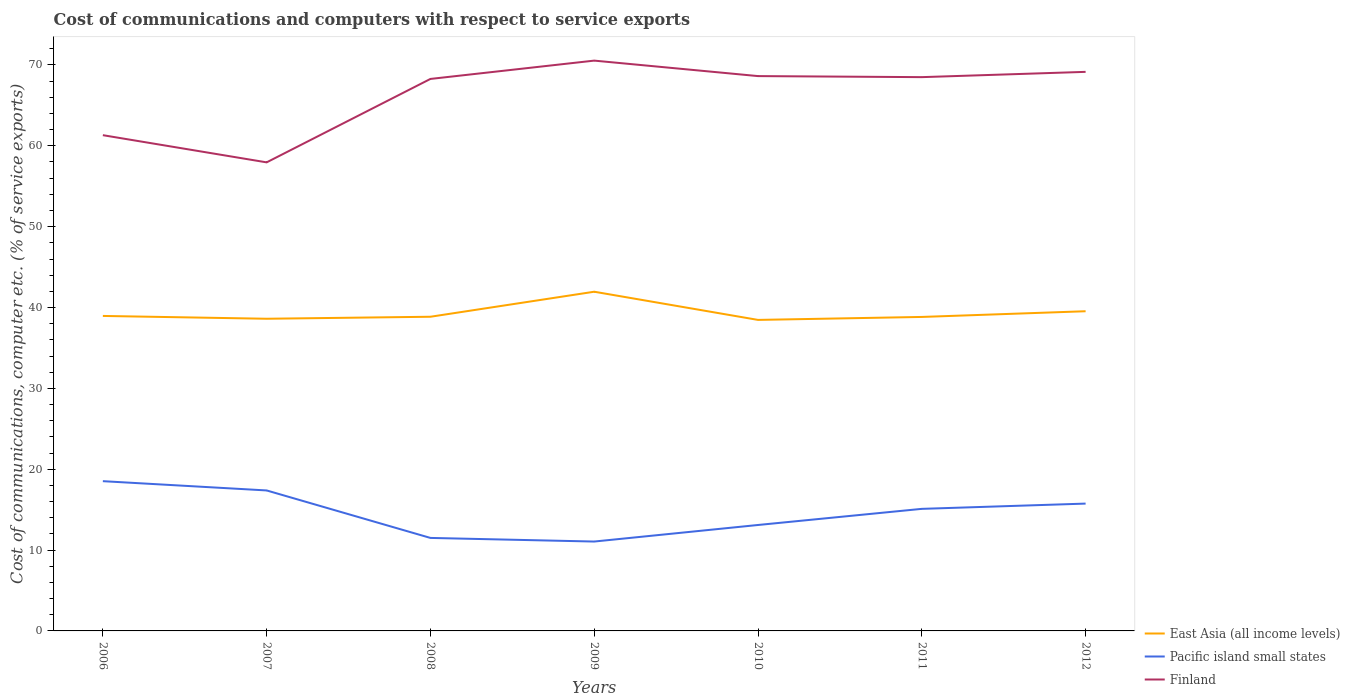Is the number of lines equal to the number of legend labels?
Your response must be concise. Yes. Across all years, what is the maximum cost of communications and computers in Finland?
Offer a very short reply. 57.95. What is the total cost of communications and computers in East Asia (all income levels) in the graph?
Provide a succinct answer. -0.25. What is the difference between the highest and the second highest cost of communications and computers in Finland?
Ensure brevity in your answer.  12.58. What is the difference between the highest and the lowest cost of communications and computers in East Asia (all income levels)?
Your answer should be compact. 2. Is the cost of communications and computers in Pacific island small states strictly greater than the cost of communications and computers in East Asia (all income levels) over the years?
Keep it short and to the point. Yes. Does the graph contain grids?
Offer a terse response. No. Where does the legend appear in the graph?
Offer a very short reply. Bottom right. What is the title of the graph?
Keep it short and to the point. Cost of communications and computers with respect to service exports. What is the label or title of the Y-axis?
Keep it short and to the point. Cost of communications, computer etc. (% of service exports). What is the Cost of communications, computer etc. (% of service exports) of East Asia (all income levels) in 2006?
Your answer should be very brief. 38.96. What is the Cost of communications, computer etc. (% of service exports) of Pacific island small states in 2006?
Keep it short and to the point. 18.52. What is the Cost of communications, computer etc. (% of service exports) in Finland in 2006?
Provide a succinct answer. 61.32. What is the Cost of communications, computer etc. (% of service exports) of East Asia (all income levels) in 2007?
Provide a short and direct response. 38.61. What is the Cost of communications, computer etc. (% of service exports) in Pacific island small states in 2007?
Provide a short and direct response. 17.37. What is the Cost of communications, computer etc. (% of service exports) of Finland in 2007?
Offer a very short reply. 57.95. What is the Cost of communications, computer etc. (% of service exports) of East Asia (all income levels) in 2008?
Your response must be concise. 38.86. What is the Cost of communications, computer etc. (% of service exports) in Pacific island small states in 2008?
Your response must be concise. 11.5. What is the Cost of communications, computer etc. (% of service exports) of Finland in 2008?
Keep it short and to the point. 68.27. What is the Cost of communications, computer etc. (% of service exports) in East Asia (all income levels) in 2009?
Ensure brevity in your answer.  41.95. What is the Cost of communications, computer etc. (% of service exports) in Pacific island small states in 2009?
Offer a very short reply. 11.06. What is the Cost of communications, computer etc. (% of service exports) in Finland in 2009?
Your answer should be compact. 70.54. What is the Cost of communications, computer etc. (% of service exports) of East Asia (all income levels) in 2010?
Your response must be concise. 38.47. What is the Cost of communications, computer etc. (% of service exports) in Pacific island small states in 2010?
Make the answer very short. 13.1. What is the Cost of communications, computer etc. (% of service exports) in Finland in 2010?
Ensure brevity in your answer.  68.62. What is the Cost of communications, computer etc. (% of service exports) in East Asia (all income levels) in 2011?
Make the answer very short. 38.84. What is the Cost of communications, computer etc. (% of service exports) in Pacific island small states in 2011?
Your answer should be very brief. 15.1. What is the Cost of communications, computer etc. (% of service exports) in Finland in 2011?
Your response must be concise. 68.5. What is the Cost of communications, computer etc. (% of service exports) in East Asia (all income levels) in 2012?
Ensure brevity in your answer.  39.54. What is the Cost of communications, computer etc. (% of service exports) in Pacific island small states in 2012?
Your response must be concise. 15.75. What is the Cost of communications, computer etc. (% of service exports) in Finland in 2012?
Give a very brief answer. 69.15. Across all years, what is the maximum Cost of communications, computer etc. (% of service exports) of East Asia (all income levels)?
Give a very brief answer. 41.95. Across all years, what is the maximum Cost of communications, computer etc. (% of service exports) in Pacific island small states?
Provide a short and direct response. 18.52. Across all years, what is the maximum Cost of communications, computer etc. (% of service exports) in Finland?
Provide a succinct answer. 70.54. Across all years, what is the minimum Cost of communications, computer etc. (% of service exports) of East Asia (all income levels)?
Offer a terse response. 38.47. Across all years, what is the minimum Cost of communications, computer etc. (% of service exports) in Pacific island small states?
Give a very brief answer. 11.06. Across all years, what is the minimum Cost of communications, computer etc. (% of service exports) of Finland?
Keep it short and to the point. 57.95. What is the total Cost of communications, computer etc. (% of service exports) of East Asia (all income levels) in the graph?
Keep it short and to the point. 275.23. What is the total Cost of communications, computer etc. (% of service exports) of Pacific island small states in the graph?
Your answer should be very brief. 102.4. What is the total Cost of communications, computer etc. (% of service exports) in Finland in the graph?
Your answer should be compact. 464.35. What is the difference between the Cost of communications, computer etc. (% of service exports) of East Asia (all income levels) in 2006 and that in 2007?
Offer a very short reply. 0.35. What is the difference between the Cost of communications, computer etc. (% of service exports) of Pacific island small states in 2006 and that in 2007?
Your response must be concise. 1.15. What is the difference between the Cost of communications, computer etc. (% of service exports) in Finland in 2006 and that in 2007?
Your answer should be compact. 3.36. What is the difference between the Cost of communications, computer etc. (% of service exports) of East Asia (all income levels) in 2006 and that in 2008?
Your response must be concise. 0.1. What is the difference between the Cost of communications, computer etc. (% of service exports) in Pacific island small states in 2006 and that in 2008?
Your answer should be very brief. 7.02. What is the difference between the Cost of communications, computer etc. (% of service exports) of Finland in 2006 and that in 2008?
Your answer should be compact. -6.96. What is the difference between the Cost of communications, computer etc. (% of service exports) of East Asia (all income levels) in 2006 and that in 2009?
Your response must be concise. -2.99. What is the difference between the Cost of communications, computer etc. (% of service exports) in Pacific island small states in 2006 and that in 2009?
Provide a short and direct response. 7.47. What is the difference between the Cost of communications, computer etc. (% of service exports) of Finland in 2006 and that in 2009?
Ensure brevity in your answer.  -9.22. What is the difference between the Cost of communications, computer etc. (% of service exports) in East Asia (all income levels) in 2006 and that in 2010?
Your answer should be compact. 0.49. What is the difference between the Cost of communications, computer etc. (% of service exports) of Pacific island small states in 2006 and that in 2010?
Your response must be concise. 5.42. What is the difference between the Cost of communications, computer etc. (% of service exports) of Finland in 2006 and that in 2010?
Give a very brief answer. -7.31. What is the difference between the Cost of communications, computer etc. (% of service exports) of East Asia (all income levels) in 2006 and that in 2011?
Provide a succinct answer. 0.12. What is the difference between the Cost of communications, computer etc. (% of service exports) of Pacific island small states in 2006 and that in 2011?
Provide a short and direct response. 3.42. What is the difference between the Cost of communications, computer etc. (% of service exports) in Finland in 2006 and that in 2011?
Your answer should be very brief. -7.18. What is the difference between the Cost of communications, computer etc. (% of service exports) of East Asia (all income levels) in 2006 and that in 2012?
Your answer should be compact. -0.58. What is the difference between the Cost of communications, computer etc. (% of service exports) in Pacific island small states in 2006 and that in 2012?
Offer a terse response. 2.77. What is the difference between the Cost of communications, computer etc. (% of service exports) in Finland in 2006 and that in 2012?
Make the answer very short. -7.83. What is the difference between the Cost of communications, computer etc. (% of service exports) of East Asia (all income levels) in 2007 and that in 2008?
Ensure brevity in your answer.  -0.25. What is the difference between the Cost of communications, computer etc. (% of service exports) of Pacific island small states in 2007 and that in 2008?
Provide a succinct answer. 5.87. What is the difference between the Cost of communications, computer etc. (% of service exports) of Finland in 2007 and that in 2008?
Ensure brevity in your answer.  -10.32. What is the difference between the Cost of communications, computer etc. (% of service exports) in East Asia (all income levels) in 2007 and that in 2009?
Your answer should be compact. -3.34. What is the difference between the Cost of communications, computer etc. (% of service exports) in Pacific island small states in 2007 and that in 2009?
Give a very brief answer. 6.32. What is the difference between the Cost of communications, computer etc. (% of service exports) in Finland in 2007 and that in 2009?
Provide a short and direct response. -12.58. What is the difference between the Cost of communications, computer etc. (% of service exports) of East Asia (all income levels) in 2007 and that in 2010?
Make the answer very short. 0.14. What is the difference between the Cost of communications, computer etc. (% of service exports) of Pacific island small states in 2007 and that in 2010?
Your answer should be compact. 4.27. What is the difference between the Cost of communications, computer etc. (% of service exports) of Finland in 2007 and that in 2010?
Your answer should be very brief. -10.67. What is the difference between the Cost of communications, computer etc. (% of service exports) of East Asia (all income levels) in 2007 and that in 2011?
Ensure brevity in your answer.  -0.22. What is the difference between the Cost of communications, computer etc. (% of service exports) of Pacific island small states in 2007 and that in 2011?
Give a very brief answer. 2.28. What is the difference between the Cost of communications, computer etc. (% of service exports) of Finland in 2007 and that in 2011?
Make the answer very short. -10.54. What is the difference between the Cost of communications, computer etc. (% of service exports) in East Asia (all income levels) in 2007 and that in 2012?
Make the answer very short. -0.93. What is the difference between the Cost of communications, computer etc. (% of service exports) of Pacific island small states in 2007 and that in 2012?
Offer a terse response. 1.63. What is the difference between the Cost of communications, computer etc. (% of service exports) of Finland in 2007 and that in 2012?
Make the answer very short. -11.19. What is the difference between the Cost of communications, computer etc. (% of service exports) of East Asia (all income levels) in 2008 and that in 2009?
Your response must be concise. -3.1. What is the difference between the Cost of communications, computer etc. (% of service exports) of Pacific island small states in 2008 and that in 2009?
Your answer should be very brief. 0.45. What is the difference between the Cost of communications, computer etc. (% of service exports) in Finland in 2008 and that in 2009?
Offer a terse response. -2.26. What is the difference between the Cost of communications, computer etc. (% of service exports) of East Asia (all income levels) in 2008 and that in 2010?
Provide a short and direct response. 0.39. What is the difference between the Cost of communications, computer etc. (% of service exports) of Pacific island small states in 2008 and that in 2010?
Keep it short and to the point. -1.6. What is the difference between the Cost of communications, computer etc. (% of service exports) in Finland in 2008 and that in 2010?
Make the answer very short. -0.35. What is the difference between the Cost of communications, computer etc. (% of service exports) in East Asia (all income levels) in 2008 and that in 2011?
Make the answer very short. 0.02. What is the difference between the Cost of communications, computer etc. (% of service exports) of Pacific island small states in 2008 and that in 2011?
Give a very brief answer. -3.6. What is the difference between the Cost of communications, computer etc. (% of service exports) in Finland in 2008 and that in 2011?
Your answer should be very brief. -0.22. What is the difference between the Cost of communications, computer etc. (% of service exports) in East Asia (all income levels) in 2008 and that in 2012?
Keep it short and to the point. -0.68. What is the difference between the Cost of communications, computer etc. (% of service exports) of Pacific island small states in 2008 and that in 2012?
Provide a succinct answer. -4.25. What is the difference between the Cost of communications, computer etc. (% of service exports) of Finland in 2008 and that in 2012?
Your response must be concise. -0.87. What is the difference between the Cost of communications, computer etc. (% of service exports) in East Asia (all income levels) in 2009 and that in 2010?
Your answer should be very brief. 3.49. What is the difference between the Cost of communications, computer etc. (% of service exports) in Pacific island small states in 2009 and that in 2010?
Your answer should be compact. -2.05. What is the difference between the Cost of communications, computer etc. (% of service exports) in Finland in 2009 and that in 2010?
Make the answer very short. 1.91. What is the difference between the Cost of communications, computer etc. (% of service exports) in East Asia (all income levels) in 2009 and that in 2011?
Your response must be concise. 3.12. What is the difference between the Cost of communications, computer etc. (% of service exports) in Pacific island small states in 2009 and that in 2011?
Your answer should be very brief. -4.04. What is the difference between the Cost of communications, computer etc. (% of service exports) of Finland in 2009 and that in 2011?
Give a very brief answer. 2.04. What is the difference between the Cost of communications, computer etc. (% of service exports) in East Asia (all income levels) in 2009 and that in 2012?
Give a very brief answer. 2.41. What is the difference between the Cost of communications, computer etc. (% of service exports) in Pacific island small states in 2009 and that in 2012?
Make the answer very short. -4.69. What is the difference between the Cost of communications, computer etc. (% of service exports) in Finland in 2009 and that in 2012?
Your response must be concise. 1.39. What is the difference between the Cost of communications, computer etc. (% of service exports) of East Asia (all income levels) in 2010 and that in 2011?
Offer a terse response. -0.37. What is the difference between the Cost of communications, computer etc. (% of service exports) in Pacific island small states in 2010 and that in 2011?
Make the answer very short. -2. What is the difference between the Cost of communications, computer etc. (% of service exports) of Finland in 2010 and that in 2011?
Ensure brevity in your answer.  0.13. What is the difference between the Cost of communications, computer etc. (% of service exports) of East Asia (all income levels) in 2010 and that in 2012?
Make the answer very short. -1.07. What is the difference between the Cost of communications, computer etc. (% of service exports) in Pacific island small states in 2010 and that in 2012?
Offer a terse response. -2.65. What is the difference between the Cost of communications, computer etc. (% of service exports) of Finland in 2010 and that in 2012?
Offer a terse response. -0.52. What is the difference between the Cost of communications, computer etc. (% of service exports) in East Asia (all income levels) in 2011 and that in 2012?
Your answer should be very brief. -0.71. What is the difference between the Cost of communications, computer etc. (% of service exports) of Pacific island small states in 2011 and that in 2012?
Give a very brief answer. -0.65. What is the difference between the Cost of communications, computer etc. (% of service exports) of Finland in 2011 and that in 2012?
Your answer should be compact. -0.65. What is the difference between the Cost of communications, computer etc. (% of service exports) in East Asia (all income levels) in 2006 and the Cost of communications, computer etc. (% of service exports) in Pacific island small states in 2007?
Give a very brief answer. 21.58. What is the difference between the Cost of communications, computer etc. (% of service exports) of East Asia (all income levels) in 2006 and the Cost of communications, computer etc. (% of service exports) of Finland in 2007?
Keep it short and to the point. -19. What is the difference between the Cost of communications, computer etc. (% of service exports) of Pacific island small states in 2006 and the Cost of communications, computer etc. (% of service exports) of Finland in 2007?
Your answer should be very brief. -39.43. What is the difference between the Cost of communications, computer etc. (% of service exports) of East Asia (all income levels) in 2006 and the Cost of communications, computer etc. (% of service exports) of Pacific island small states in 2008?
Provide a succinct answer. 27.46. What is the difference between the Cost of communications, computer etc. (% of service exports) in East Asia (all income levels) in 2006 and the Cost of communications, computer etc. (% of service exports) in Finland in 2008?
Provide a succinct answer. -29.31. What is the difference between the Cost of communications, computer etc. (% of service exports) of Pacific island small states in 2006 and the Cost of communications, computer etc. (% of service exports) of Finland in 2008?
Make the answer very short. -49.75. What is the difference between the Cost of communications, computer etc. (% of service exports) in East Asia (all income levels) in 2006 and the Cost of communications, computer etc. (% of service exports) in Pacific island small states in 2009?
Give a very brief answer. 27.9. What is the difference between the Cost of communications, computer etc. (% of service exports) in East Asia (all income levels) in 2006 and the Cost of communications, computer etc. (% of service exports) in Finland in 2009?
Your answer should be compact. -31.58. What is the difference between the Cost of communications, computer etc. (% of service exports) of Pacific island small states in 2006 and the Cost of communications, computer etc. (% of service exports) of Finland in 2009?
Provide a short and direct response. -52.02. What is the difference between the Cost of communications, computer etc. (% of service exports) of East Asia (all income levels) in 2006 and the Cost of communications, computer etc. (% of service exports) of Pacific island small states in 2010?
Your answer should be very brief. 25.86. What is the difference between the Cost of communications, computer etc. (% of service exports) of East Asia (all income levels) in 2006 and the Cost of communications, computer etc. (% of service exports) of Finland in 2010?
Make the answer very short. -29.67. What is the difference between the Cost of communications, computer etc. (% of service exports) in Pacific island small states in 2006 and the Cost of communications, computer etc. (% of service exports) in Finland in 2010?
Provide a succinct answer. -50.1. What is the difference between the Cost of communications, computer etc. (% of service exports) in East Asia (all income levels) in 2006 and the Cost of communications, computer etc. (% of service exports) in Pacific island small states in 2011?
Your response must be concise. 23.86. What is the difference between the Cost of communications, computer etc. (% of service exports) in East Asia (all income levels) in 2006 and the Cost of communications, computer etc. (% of service exports) in Finland in 2011?
Ensure brevity in your answer.  -29.54. What is the difference between the Cost of communications, computer etc. (% of service exports) of Pacific island small states in 2006 and the Cost of communications, computer etc. (% of service exports) of Finland in 2011?
Make the answer very short. -49.97. What is the difference between the Cost of communications, computer etc. (% of service exports) in East Asia (all income levels) in 2006 and the Cost of communications, computer etc. (% of service exports) in Pacific island small states in 2012?
Give a very brief answer. 23.21. What is the difference between the Cost of communications, computer etc. (% of service exports) of East Asia (all income levels) in 2006 and the Cost of communications, computer etc. (% of service exports) of Finland in 2012?
Offer a very short reply. -30.19. What is the difference between the Cost of communications, computer etc. (% of service exports) in Pacific island small states in 2006 and the Cost of communications, computer etc. (% of service exports) in Finland in 2012?
Your response must be concise. -50.63. What is the difference between the Cost of communications, computer etc. (% of service exports) of East Asia (all income levels) in 2007 and the Cost of communications, computer etc. (% of service exports) of Pacific island small states in 2008?
Offer a terse response. 27.11. What is the difference between the Cost of communications, computer etc. (% of service exports) in East Asia (all income levels) in 2007 and the Cost of communications, computer etc. (% of service exports) in Finland in 2008?
Your answer should be very brief. -29.66. What is the difference between the Cost of communications, computer etc. (% of service exports) in Pacific island small states in 2007 and the Cost of communications, computer etc. (% of service exports) in Finland in 2008?
Make the answer very short. -50.9. What is the difference between the Cost of communications, computer etc. (% of service exports) of East Asia (all income levels) in 2007 and the Cost of communications, computer etc. (% of service exports) of Pacific island small states in 2009?
Provide a succinct answer. 27.56. What is the difference between the Cost of communications, computer etc. (% of service exports) in East Asia (all income levels) in 2007 and the Cost of communications, computer etc. (% of service exports) in Finland in 2009?
Provide a short and direct response. -31.93. What is the difference between the Cost of communications, computer etc. (% of service exports) of Pacific island small states in 2007 and the Cost of communications, computer etc. (% of service exports) of Finland in 2009?
Give a very brief answer. -53.16. What is the difference between the Cost of communications, computer etc. (% of service exports) of East Asia (all income levels) in 2007 and the Cost of communications, computer etc. (% of service exports) of Pacific island small states in 2010?
Your response must be concise. 25.51. What is the difference between the Cost of communications, computer etc. (% of service exports) of East Asia (all income levels) in 2007 and the Cost of communications, computer etc. (% of service exports) of Finland in 2010?
Offer a very short reply. -30.01. What is the difference between the Cost of communications, computer etc. (% of service exports) in Pacific island small states in 2007 and the Cost of communications, computer etc. (% of service exports) in Finland in 2010?
Give a very brief answer. -51.25. What is the difference between the Cost of communications, computer etc. (% of service exports) in East Asia (all income levels) in 2007 and the Cost of communications, computer etc. (% of service exports) in Pacific island small states in 2011?
Your response must be concise. 23.51. What is the difference between the Cost of communications, computer etc. (% of service exports) in East Asia (all income levels) in 2007 and the Cost of communications, computer etc. (% of service exports) in Finland in 2011?
Give a very brief answer. -29.88. What is the difference between the Cost of communications, computer etc. (% of service exports) in Pacific island small states in 2007 and the Cost of communications, computer etc. (% of service exports) in Finland in 2011?
Offer a terse response. -51.12. What is the difference between the Cost of communications, computer etc. (% of service exports) of East Asia (all income levels) in 2007 and the Cost of communications, computer etc. (% of service exports) of Pacific island small states in 2012?
Keep it short and to the point. 22.86. What is the difference between the Cost of communications, computer etc. (% of service exports) in East Asia (all income levels) in 2007 and the Cost of communications, computer etc. (% of service exports) in Finland in 2012?
Offer a terse response. -30.54. What is the difference between the Cost of communications, computer etc. (% of service exports) in Pacific island small states in 2007 and the Cost of communications, computer etc. (% of service exports) in Finland in 2012?
Provide a succinct answer. -51.77. What is the difference between the Cost of communications, computer etc. (% of service exports) in East Asia (all income levels) in 2008 and the Cost of communications, computer etc. (% of service exports) in Pacific island small states in 2009?
Your answer should be compact. 27.8. What is the difference between the Cost of communications, computer etc. (% of service exports) in East Asia (all income levels) in 2008 and the Cost of communications, computer etc. (% of service exports) in Finland in 2009?
Make the answer very short. -31.68. What is the difference between the Cost of communications, computer etc. (% of service exports) in Pacific island small states in 2008 and the Cost of communications, computer etc. (% of service exports) in Finland in 2009?
Provide a succinct answer. -59.04. What is the difference between the Cost of communications, computer etc. (% of service exports) of East Asia (all income levels) in 2008 and the Cost of communications, computer etc. (% of service exports) of Pacific island small states in 2010?
Provide a succinct answer. 25.76. What is the difference between the Cost of communications, computer etc. (% of service exports) of East Asia (all income levels) in 2008 and the Cost of communications, computer etc. (% of service exports) of Finland in 2010?
Your response must be concise. -29.77. What is the difference between the Cost of communications, computer etc. (% of service exports) in Pacific island small states in 2008 and the Cost of communications, computer etc. (% of service exports) in Finland in 2010?
Your answer should be very brief. -57.12. What is the difference between the Cost of communications, computer etc. (% of service exports) of East Asia (all income levels) in 2008 and the Cost of communications, computer etc. (% of service exports) of Pacific island small states in 2011?
Offer a terse response. 23.76. What is the difference between the Cost of communications, computer etc. (% of service exports) of East Asia (all income levels) in 2008 and the Cost of communications, computer etc. (% of service exports) of Finland in 2011?
Provide a short and direct response. -29.64. What is the difference between the Cost of communications, computer etc. (% of service exports) in Pacific island small states in 2008 and the Cost of communications, computer etc. (% of service exports) in Finland in 2011?
Provide a succinct answer. -56.99. What is the difference between the Cost of communications, computer etc. (% of service exports) in East Asia (all income levels) in 2008 and the Cost of communications, computer etc. (% of service exports) in Pacific island small states in 2012?
Keep it short and to the point. 23.11. What is the difference between the Cost of communications, computer etc. (% of service exports) in East Asia (all income levels) in 2008 and the Cost of communications, computer etc. (% of service exports) in Finland in 2012?
Offer a very short reply. -30.29. What is the difference between the Cost of communications, computer etc. (% of service exports) in Pacific island small states in 2008 and the Cost of communications, computer etc. (% of service exports) in Finland in 2012?
Make the answer very short. -57.65. What is the difference between the Cost of communications, computer etc. (% of service exports) of East Asia (all income levels) in 2009 and the Cost of communications, computer etc. (% of service exports) of Pacific island small states in 2010?
Ensure brevity in your answer.  28.85. What is the difference between the Cost of communications, computer etc. (% of service exports) of East Asia (all income levels) in 2009 and the Cost of communications, computer etc. (% of service exports) of Finland in 2010?
Provide a succinct answer. -26.67. What is the difference between the Cost of communications, computer etc. (% of service exports) of Pacific island small states in 2009 and the Cost of communications, computer etc. (% of service exports) of Finland in 2010?
Give a very brief answer. -57.57. What is the difference between the Cost of communications, computer etc. (% of service exports) of East Asia (all income levels) in 2009 and the Cost of communications, computer etc. (% of service exports) of Pacific island small states in 2011?
Keep it short and to the point. 26.86. What is the difference between the Cost of communications, computer etc. (% of service exports) of East Asia (all income levels) in 2009 and the Cost of communications, computer etc. (% of service exports) of Finland in 2011?
Your response must be concise. -26.54. What is the difference between the Cost of communications, computer etc. (% of service exports) in Pacific island small states in 2009 and the Cost of communications, computer etc. (% of service exports) in Finland in 2011?
Your response must be concise. -57.44. What is the difference between the Cost of communications, computer etc. (% of service exports) in East Asia (all income levels) in 2009 and the Cost of communications, computer etc. (% of service exports) in Pacific island small states in 2012?
Your answer should be compact. 26.2. What is the difference between the Cost of communications, computer etc. (% of service exports) in East Asia (all income levels) in 2009 and the Cost of communications, computer etc. (% of service exports) in Finland in 2012?
Make the answer very short. -27.19. What is the difference between the Cost of communications, computer etc. (% of service exports) of Pacific island small states in 2009 and the Cost of communications, computer etc. (% of service exports) of Finland in 2012?
Your answer should be compact. -58.09. What is the difference between the Cost of communications, computer etc. (% of service exports) of East Asia (all income levels) in 2010 and the Cost of communications, computer etc. (% of service exports) of Pacific island small states in 2011?
Offer a very short reply. 23.37. What is the difference between the Cost of communications, computer etc. (% of service exports) of East Asia (all income levels) in 2010 and the Cost of communications, computer etc. (% of service exports) of Finland in 2011?
Ensure brevity in your answer.  -30.03. What is the difference between the Cost of communications, computer etc. (% of service exports) of Pacific island small states in 2010 and the Cost of communications, computer etc. (% of service exports) of Finland in 2011?
Ensure brevity in your answer.  -55.39. What is the difference between the Cost of communications, computer etc. (% of service exports) in East Asia (all income levels) in 2010 and the Cost of communications, computer etc. (% of service exports) in Pacific island small states in 2012?
Provide a succinct answer. 22.72. What is the difference between the Cost of communications, computer etc. (% of service exports) of East Asia (all income levels) in 2010 and the Cost of communications, computer etc. (% of service exports) of Finland in 2012?
Your answer should be very brief. -30.68. What is the difference between the Cost of communications, computer etc. (% of service exports) of Pacific island small states in 2010 and the Cost of communications, computer etc. (% of service exports) of Finland in 2012?
Give a very brief answer. -56.04. What is the difference between the Cost of communications, computer etc. (% of service exports) of East Asia (all income levels) in 2011 and the Cost of communications, computer etc. (% of service exports) of Pacific island small states in 2012?
Your response must be concise. 23.09. What is the difference between the Cost of communications, computer etc. (% of service exports) of East Asia (all income levels) in 2011 and the Cost of communications, computer etc. (% of service exports) of Finland in 2012?
Your answer should be compact. -30.31. What is the difference between the Cost of communications, computer etc. (% of service exports) in Pacific island small states in 2011 and the Cost of communications, computer etc. (% of service exports) in Finland in 2012?
Ensure brevity in your answer.  -54.05. What is the average Cost of communications, computer etc. (% of service exports) of East Asia (all income levels) per year?
Your answer should be very brief. 39.32. What is the average Cost of communications, computer etc. (% of service exports) in Pacific island small states per year?
Your answer should be compact. 14.63. What is the average Cost of communications, computer etc. (% of service exports) in Finland per year?
Give a very brief answer. 66.34. In the year 2006, what is the difference between the Cost of communications, computer etc. (% of service exports) in East Asia (all income levels) and Cost of communications, computer etc. (% of service exports) in Pacific island small states?
Offer a terse response. 20.44. In the year 2006, what is the difference between the Cost of communications, computer etc. (% of service exports) in East Asia (all income levels) and Cost of communications, computer etc. (% of service exports) in Finland?
Offer a very short reply. -22.36. In the year 2006, what is the difference between the Cost of communications, computer etc. (% of service exports) of Pacific island small states and Cost of communications, computer etc. (% of service exports) of Finland?
Offer a terse response. -42.8. In the year 2007, what is the difference between the Cost of communications, computer etc. (% of service exports) of East Asia (all income levels) and Cost of communications, computer etc. (% of service exports) of Pacific island small states?
Provide a short and direct response. 21.24. In the year 2007, what is the difference between the Cost of communications, computer etc. (% of service exports) in East Asia (all income levels) and Cost of communications, computer etc. (% of service exports) in Finland?
Offer a very short reply. -19.34. In the year 2007, what is the difference between the Cost of communications, computer etc. (% of service exports) in Pacific island small states and Cost of communications, computer etc. (% of service exports) in Finland?
Provide a succinct answer. -40.58. In the year 2008, what is the difference between the Cost of communications, computer etc. (% of service exports) in East Asia (all income levels) and Cost of communications, computer etc. (% of service exports) in Pacific island small states?
Offer a terse response. 27.36. In the year 2008, what is the difference between the Cost of communications, computer etc. (% of service exports) of East Asia (all income levels) and Cost of communications, computer etc. (% of service exports) of Finland?
Your answer should be compact. -29.42. In the year 2008, what is the difference between the Cost of communications, computer etc. (% of service exports) of Pacific island small states and Cost of communications, computer etc. (% of service exports) of Finland?
Make the answer very short. -56.77. In the year 2009, what is the difference between the Cost of communications, computer etc. (% of service exports) in East Asia (all income levels) and Cost of communications, computer etc. (% of service exports) in Pacific island small states?
Ensure brevity in your answer.  30.9. In the year 2009, what is the difference between the Cost of communications, computer etc. (% of service exports) in East Asia (all income levels) and Cost of communications, computer etc. (% of service exports) in Finland?
Your answer should be compact. -28.58. In the year 2009, what is the difference between the Cost of communications, computer etc. (% of service exports) in Pacific island small states and Cost of communications, computer etc. (% of service exports) in Finland?
Provide a succinct answer. -59.48. In the year 2010, what is the difference between the Cost of communications, computer etc. (% of service exports) of East Asia (all income levels) and Cost of communications, computer etc. (% of service exports) of Pacific island small states?
Your response must be concise. 25.36. In the year 2010, what is the difference between the Cost of communications, computer etc. (% of service exports) of East Asia (all income levels) and Cost of communications, computer etc. (% of service exports) of Finland?
Offer a terse response. -30.16. In the year 2010, what is the difference between the Cost of communications, computer etc. (% of service exports) in Pacific island small states and Cost of communications, computer etc. (% of service exports) in Finland?
Ensure brevity in your answer.  -55.52. In the year 2011, what is the difference between the Cost of communications, computer etc. (% of service exports) of East Asia (all income levels) and Cost of communications, computer etc. (% of service exports) of Pacific island small states?
Offer a terse response. 23.74. In the year 2011, what is the difference between the Cost of communications, computer etc. (% of service exports) in East Asia (all income levels) and Cost of communications, computer etc. (% of service exports) in Finland?
Ensure brevity in your answer.  -29.66. In the year 2011, what is the difference between the Cost of communications, computer etc. (% of service exports) of Pacific island small states and Cost of communications, computer etc. (% of service exports) of Finland?
Keep it short and to the point. -53.4. In the year 2012, what is the difference between the Cost of communications, computer etc. (% of service exports) of East Asia (all income levels) and Cost of communications, computer etc. (% of service exports) of Pacific island small states?
Your response must be concise. 23.79. In the year 2012, what is the difference between the Cost of communications, computer etc. (% of service exports) of East Asia (all income levels) and Cost of communications, computer etc. (% of service exports) of Finland?
Your response must be concise. -29.61. In the year 2012, what is the difference between the Cost of communications, computer etc. (% of service exports) in Pacific island small states and Cost of communications, computer etc. (% of service exports) in Finland?
Offer a terse response. -53.4. What is the ratio of the Cost of communications, computer etc. (% of service exports) in Pacific island small states in 2006 to that in 2007?
Make the answer very short. 1.07. What is the ratio of the Cost of communications, computer etc. (% of service exports) in Finland in 2006 to that in 2007?
Provide a short and direct response. 1.06. What is the ratio of the Cost of communications, computer etc. (% of service exports) of Pacific island small states in 2006 to that in 2008?
Your answer should be very brief. 1.61. What is the ratio of the Cost of communications, computer etc. (% of service exports) in Finland in 2006 to that in 2008?
Make the answer very short. 0.9. What is the ratio of the Cost of communications, computer etc. (% of service exports) of East Asia (all income levels) in 2006 to that in 2009?
Provide a short and direct response. 0.93. What is the ratio of the Cost of communications, computer etc. (% of service exports) of Pacific island small states in 2006 to that in 2009?
Your response must be concise. 1.68. What is the ratio of the Cost of communications, computer etc. (% of service exports) in Finland in 2006 to that in 2009?
Provide a succinct answer. 0.87. What is the ratio of the Cost of communications, computer etc. (% of service exports) of East Asia (all income levels) in 2006 to that in 2010?
Provide a short and direct response. 1.01. What is the ratio of the Cost of communications, computer etc. (% of service exports) in Pacific island small states in 2006 to that in 2010?
Ensure brevity in your answer.  1.41. What is the ratio of the Cost of communications, computer etc. (% of service exports) of Finland in 2006 to that in 2010?
Keep it short and to the point. 0.89. What is the ratio of the Cost of communications, computer etc. (% of service exports) of Pacific island small states in 2006 to that in 2011?
Offer a terse response. 1.23. What is the ratio of the Cost of communications, computer etc. (% of service exports) in Finland in 2006 to that in 2011?
Give a very brief answer. 0.9. What is the ratio of the Cost of communications, computer etc. (% of service exports) of Pacific island small states in 2006 to that in 2012?
Make the answer very short. 1.18. What is the ratio of the Cost of communications, computer etc. (% of service exports) of Finland in 2006 to that in 2012?
Offer a very short reply. 0.89. What is the ratio of the Cost of communications, computer etc. (% of service exports) in East Asia (all income levels) in 2007 to that in 2008?
Provide a short and direct response. 0.99. What is the ratio of the Cost of communications, computer etc. (% of service exports) in Pacific island small states in 2007 to that in 2008?
Your answer should be very brief. 1.51. What is the ratio of the Cost of communications, computer etc. (% of service exports) in Finland in 2007 to that in 2008?
Provide a short and direct response. 0.85. What is the ratio of the Cost of communications, computer etc. (% of service exports) in East Asia (all income levels) in 2007 to that in 2009?
Your response must be concise. 0.92. What is the ratio of the Cost of communications, computer etc. (% of service exports) in Pacific island small states in 2007 to that in 2009?
Provide a short and direct response. 1.57. What is the ratio of the Cost of communications, computer etc. (% of service exports) in Finland in 2007 to that in 2009?
Make the answer very short. 0.82. What is the ratio of the Cost of communications, computer etc. (% of service exports) of Pacific island small states in 2007 to that in 2010?
Give a very brief answer. 1.33. What is the ratio of the Cost of communications, computer etc. (% of service exports) in Finland in 2007 to that in 2010?
Your response must be concise. 0.84. What is the ratio of the Cost of communications, computer etc. (% of service exports) in East Asia (all income levels) in 2007 to that in 2011?
Provide a succinct answer. 0.99. What is the ratio of the Cost of communications, computer etc. (% of service exports) of Pacific island small states in 2007 to that in 2011?
Your answer should be very brief. 1.15. What is the ratio of the Cost of communications, computer etc. (% of service exports) of Finland in 2007 to that in 2011?
Your response must be concise. 0.85. What is the ratio of the Cost of communications, computer etc. (% of service exports) of East Asia (all income levels) in 2007 to that in 2012?
Offer a terse response. 0.98. What is the ratio of the Cost of communications, computer etc. (% of service exports) in Pacific island small states in 2007 to that in 2012?
Keep it short and to the point. 1.1. What is the ratio of the Cost of communications, computer etc. (% of service exports) of Finland in 2007 to that in 2012?
Provide a short and direct response. 0.84. What is the ratio of the Cost of communications, computer etc. (% of service exports) of East Asia (all income levels) in 2008 to that in 2009?
Provide a short and direct response. 0.93. What is the ratio of the Cost of communications, computer etc. (% of service exports) of Pacific island small states in 2008 to that in 2009?
Ensure brevity in your answer.  1.04. What is the ratio of the Cost of communications, computer etc. (% of service exports) in Finland in 2008 to that in 2009?
Make the answer very short. 0.97. What is the ratio of the Cost of communications, computer etc. (% of service exports) in East Asia (all income levels) in 2008 to that in 2010?
Offer a terse response. 1.01. What is the ratio of the Cost of communications, computer etc. (% of service exports) of Pacific island small states in 2008 to that in 2010?
Ensure brevity in your answer.  0.88. What is the ratio of the Cost of communications, computer etc. (% of service exports) of Pacific island small states in 2008 to that in 2011?
Make the answer very short. 0.76. What is the ratio of the Cost of communications, computer etc. (% of service exports) of East Asia (all income levels) in 2008 to that in 2012?
Your answer should be compact. 0.98. What is the ratio of the Cost of communications, computer etc. (% of service exports) of Pacific island small states in 2008 to that in 2012?
Offer a terse response. 0.73. What is the ratio of the Cost of communications, computer etc. (% of service exports) of Finland in 2008 to that in 2012?
Provide a short and direct response. 0.99. What is the ratio of the Cost of communications, computer etc. (% of service exports) of East Asia (all income levels) in 2009 to that in 2010?
Provide a succinct answer. 1.09. What is the ratio of the Cost of communications, computer etc. (% of service exports) of Pacific island small states in 2009 to that in 2010?
Your response must be concise. 0.84. What is the ratio of the Cost of communications, computer etc. (% of service exports) of Finland in 2009 to that in 2010?
Your answer should be compact. 1.03. What is the ratio of the Cost of communications, computer etc. (% of service exports) of East Asia (all income levels) in 2009 to that in 2011?
Ensure brevity in your answer.  1.08. What is the ratio of the Cost of communications, computer etc. (% of service exports) in Pacific island small states in 2009 to that in 2011?
Your answer should be compact. 0.73. What is the ratio of the Cost of communications, computer etc. (% of service exports) in Finland in 2009 to that in 2011?
Make the answer very short. 1.03. What is the ratio of the Cost of communications, computer etc. (% of service exports) in East Asia (all income levels) in 2009 to that in 2012?
Your response must be concise. 1.06. What is the ratio of the Cost of communications, computer etc. (% of service exports) of Pacific island small states in 2009 to that in 2012?
Provide a short and direct response. 0.7. What is the ratio of the Cost of communications, computer etc. (% of service exports) of Finland in 2009 to that in 2012?
Make the answer very short. 1.02. What is the ratio of the Cost of communications, computer etc. (% of service exports) of Pacific island small states in 2010 to that in 2011?
Your answer should be compact. 0.87. What is the ratio of the Cost of communications, computer etc. (% of service exports) of Finland in 2010 to that in 2011?
Offer a very short reply. 1. What is the ratio of the Cost of communications, computer etc. (% of service exports) of East Asia (all income levels) in 2010 to that in 2012?
Keep it short and to the point. 0.97. What is the ratio of the Cost of communications, computer etc. (% of service exports) in Pacific island small states in 2010 to that in 2012?
Offer a very short reply. 0.83. What is the ratio of the Cost of communications, computer etc. (% of service exports) of East Asia (all income levels) in 2011 to that in 2012?
Provide a succinct answer. 0.98. What is the ratio of the Cost of communications, computer etc. (% of service exports) of Pacific island small states in 2011 to that in 2012?
Give a very brief answer. 0.96. What is the ratio of the Cost of communications, computer etc. (% of service exports) in Finland in 2011 to that in 2012?
Your answer should be compact. 0.99. What is the difference between the highest and the second highest Cost of communications, computer etc. (% of service exports) in East Asia (all income levels)?
Keep it short and to the point. 2.41. What is the difference between the highest and the second highest Cost of communications, computer etc. (% of service exports) of Pacific island small states?
Provide a short and direct response. 1.15. What is the difference between the highest and the second highest Cost of communications, computer etc. (% of service exports) of Finland?
Give a very brief answer. 1.39. What is the difference between the highest and the lowest Cost of communications, computer etc. (% of service exports) in East Asia (all income levels)?
Provide a succinct answer. 3.49. What is the difference between the highest and the lowest Cost of communications, computer etc. (% of service exports) of Pacific island small states?
Provide a succinct answer. 7.47. What is the difference between the highest and the lowest Cost of communications, computer etc. (% of service exports) in Finland?
Give a very brief answer. 12.58. 